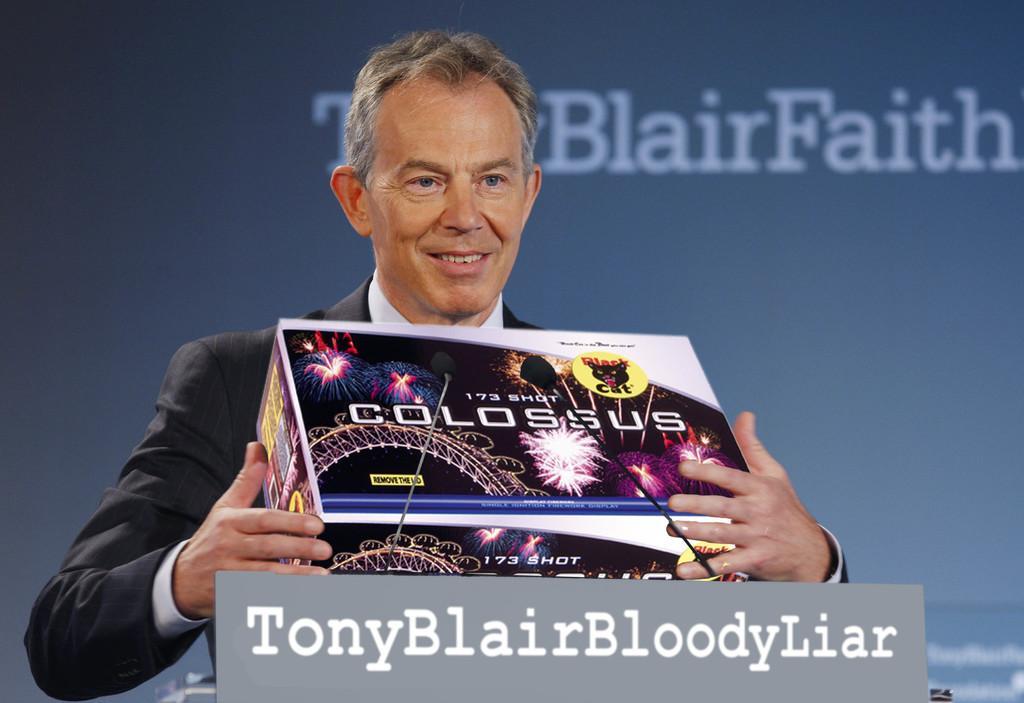Could you give a brief overview of what you see in this image? There is a man,he is holding some item in his hands and there is a mic in front of the person,behind the man there is some name on a banner and the background of the name is in grey color. 